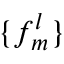Convert formula to latex. <formula><loc_0><loc_0><loc_500><loc_500>\{ f _ { m } ^ { l } \}</formula> 